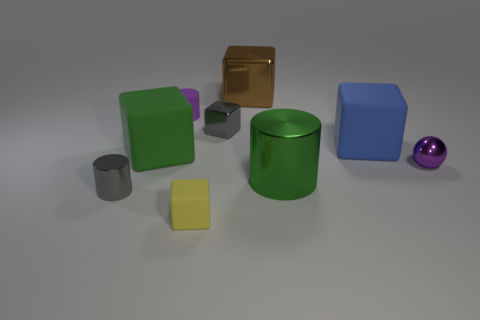Subtract all brown cubes. How many cubes are left? 4 Subtract all brown cubes. How many cubes are left? 4 Subtract all purple blocks. Subtract all green cylinders. How many blocks are left? 5 Add 1 small purple spheres. How many objects exist? 10 Subtract all cubes. How many objects are left? 4 Subtract 0 cyan cylinders. How many objects are left? 9 Subtract all yellow matte cubes. Subtract all small purple metal objects. How many objects are left? 7 Add 9 big brown objects. How many big brown objects are left? 10 Add 6 large gray metal things. How many large gray metal things exist? 6 